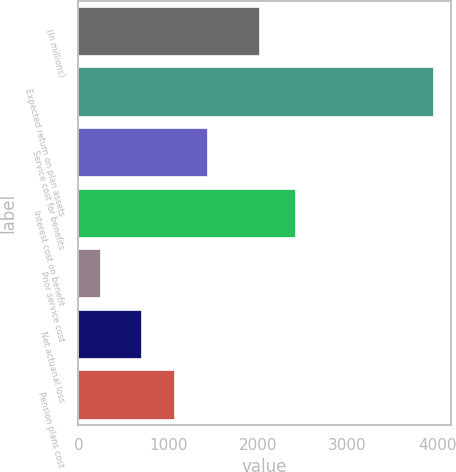Convert chart to OTSL. <chart><loc_0><loc_0><loc_500><loc_500><bar_chart><fcel>(In millions)<fcel>Expected return on plan assets<fcel>Service cost for benefits<fcel>Interest cost on benefit<fcel>Prior service cost<fcel>Net actuarial loss<fcel>Pension plans cost<nl><fcel>2007<fcel>3950<fcel>1434.8<fcel>2416<fcel>241<fcel>693<fcel>1063.9<nl></chart> 